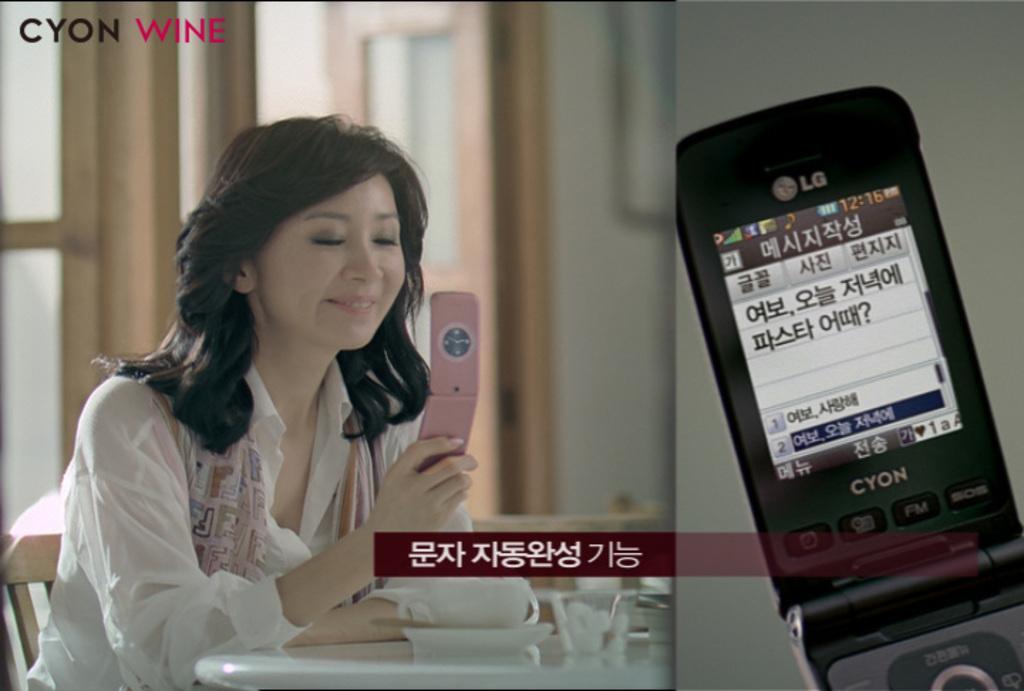How would you summarize this image in a sentence or two? In this picture we can see woman sitting on chair and smiling and holding mobile in her hand and in front of her there is table and on table we can see bowl and in background we can see door, wall and this is poster. 